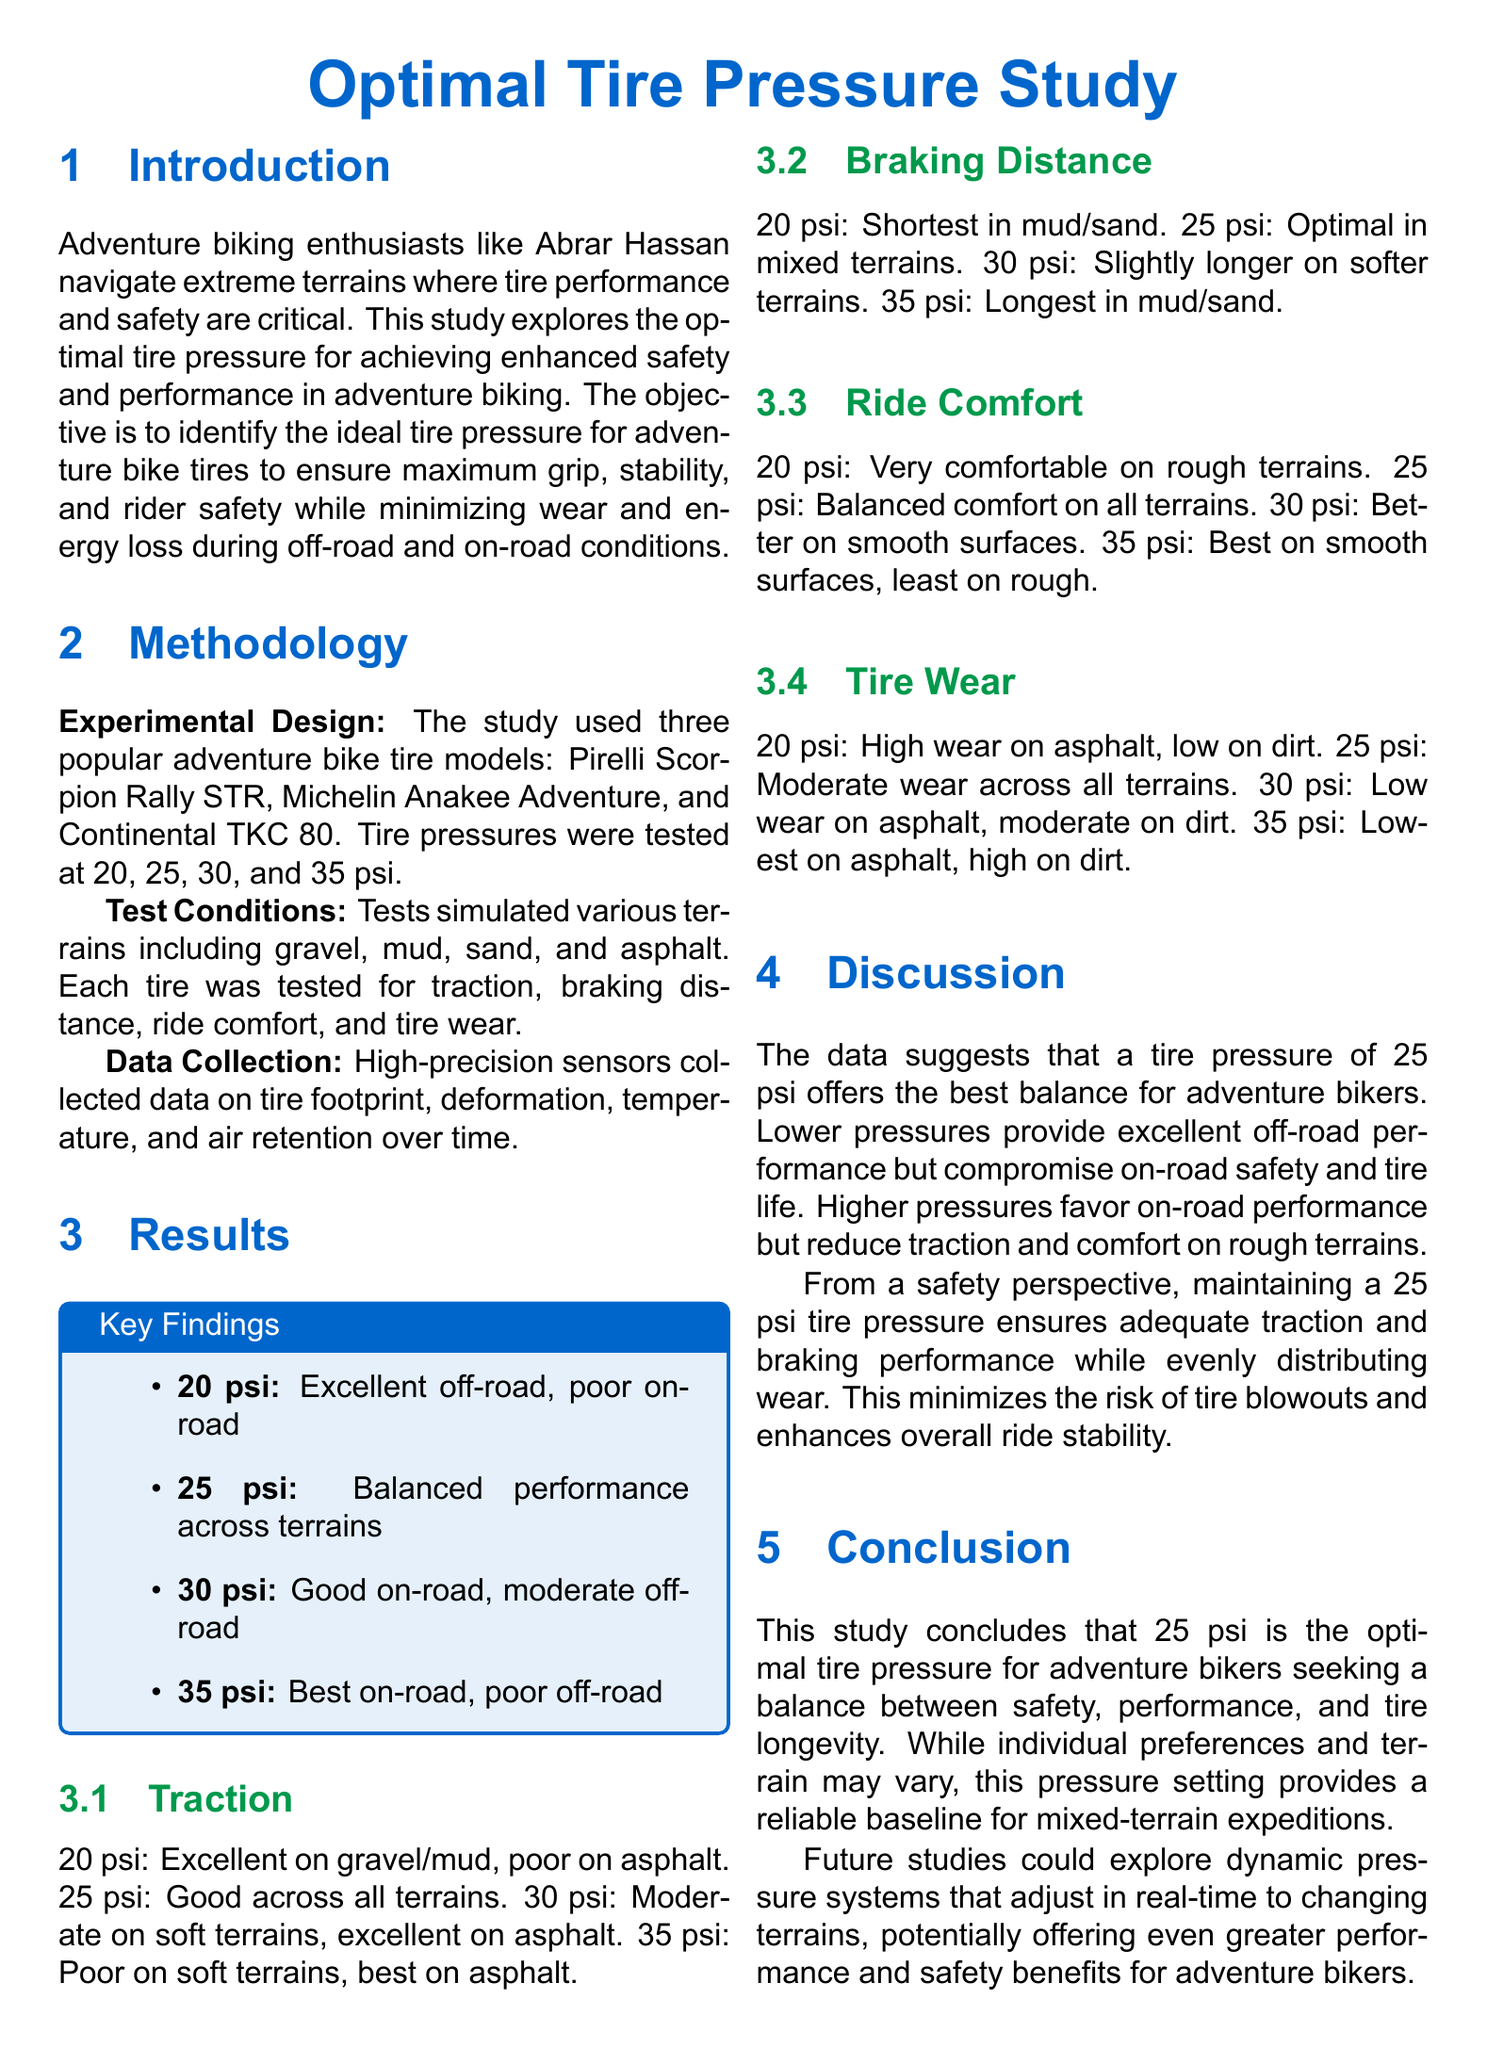What is the objective of the study? The objective is to identify the ideal tire pressure for adventure bike tires to ensure maximum grip, stability, and rider safety while minimizing wear and energy loss.
Answer: Identify the ideal tire pressure What tire pressure is considered optimal? The study concludes that 25 psi is the optimal tire pressure for adventure bikers seeking a balance between safety, performance, and tire longevity.
Answer: 25 psi Which tire model had the best performance at 30 psi? The document does not specify a particular model for 30 psi, but it states that 30 psi performed well on asphalt.
Answer: Not specified What are the test conditions used in the study? The study simulated various terrains including gravel, mud, sand, and asphalt.
Answer: Gravel, mud, sand, asphalt What was the traction performance at 20 psi on gravel? The traction performance at 20 psi was excellent on gravel.
Answer: Excellent How does 25 psi perform in terms of ride comfort? 25 psi offers balanced comfort on all terrains.
Answer: Balanced comfort What was the braking distance at 25 psi? The optimal braking distance was noted at 25 psi in mixed terrains.
Answer: Optimal in mixed terrains What is a potential future study suggestion? Future studies could explore dynamic pressure systems that adjust in real-time to changing terrains.
Answer: Dynamic pressure systems What happens to tire wear at 35 psi? At 35 psi, tire wear is lowest on asphalt and high on dirt.
Answer: Lowest on asphalt, high on dirt 